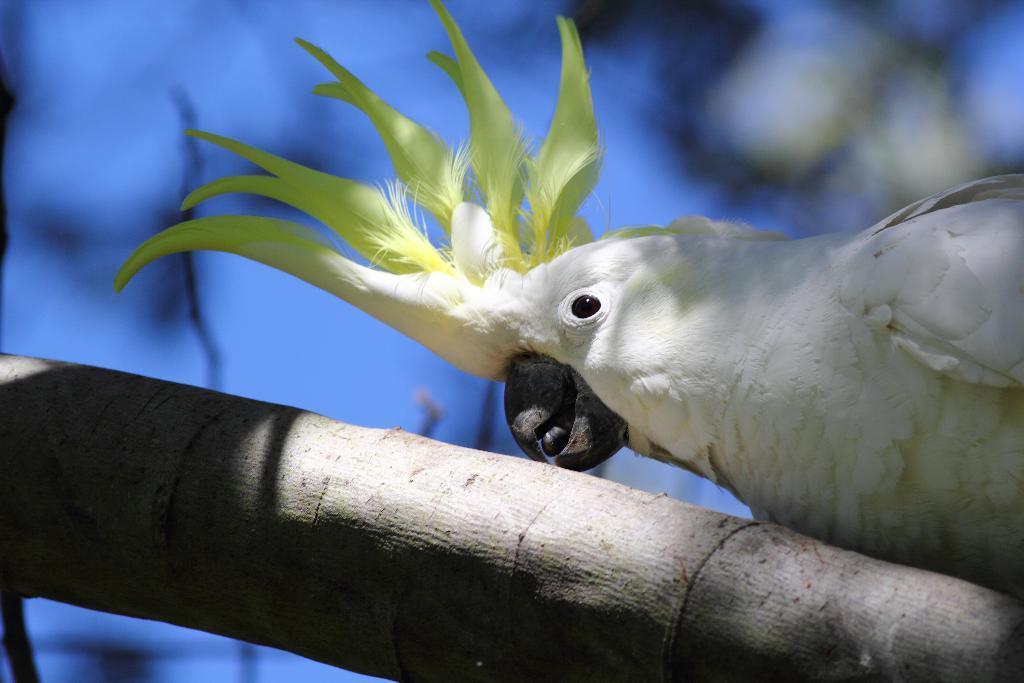Please provide a concise description of this image. In this picture I can see a bird on the branch. 